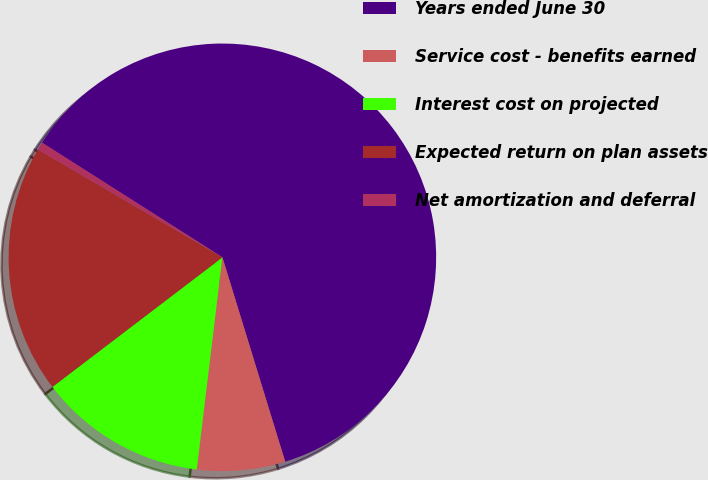<chart> <loc_0><loc_0><loc_500><loc_500><pie_chart><fcel>Years ended June 30<fcel>Service cost - benefits earned<fcel>Interest cost on projected<fcel>Expected return on plan assets<fcel>Net amortization and deferral<nl><fcel>61.25%<fcel>6.66%<fcel>12.72%<fcel>18.79%<fcel>0.59%<nl></chart> 